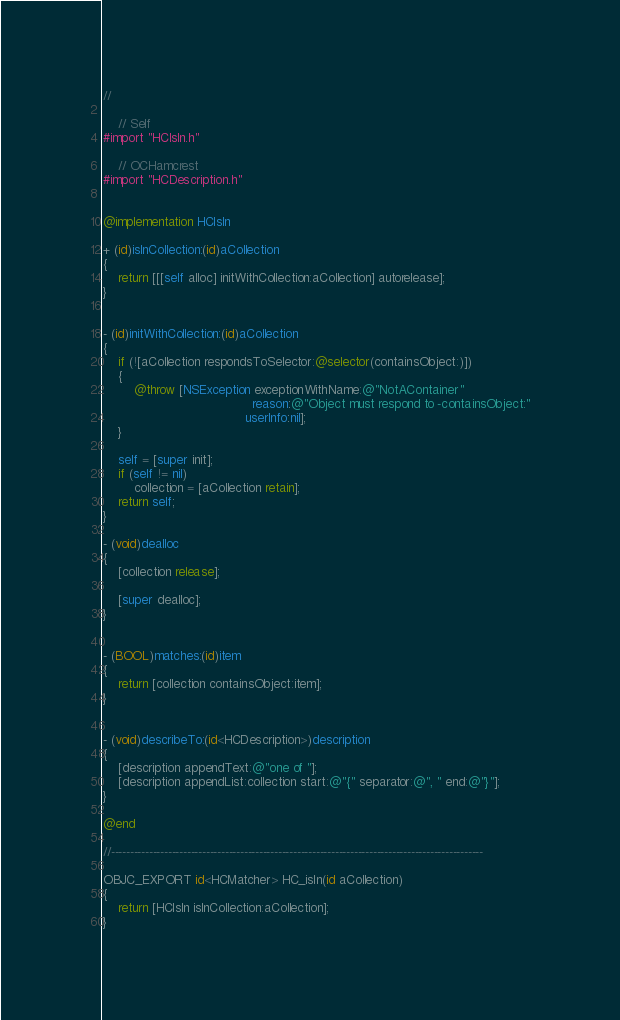<code> <loc_0><loc_0><loc_500><loc_500><_ObjectiveC_>//

    // Self
#import "HCIsIn.h"

    // OCHamcrest
#import "HCDescription.h"


@implementation HCIsIn

+ (id)isInCollection:(id)aCollection
{
    return [[[self alloc] initWithCollection:aCollection] autorelease];
}


- (id)initWithCollection:(id)aCollection
{
    if (![aCollection respondsToSelector:@selector(containsObject:)])
    {
        @throw [NSException exceptionWithName:@"NotAContainer"
                                       reason:@"Object must respond to -containsObject:"
                                     userInfo:nil];
    }
    
    self = [super init];
    if (self != nil)
        collection = [aCollection retain];
    return self;
}

- (void)dealloc
{
    [collection release];
    
    [super dealloc];
}


- (BOOL)matches:(id)item
{
    return [collection containsObject:item];
}


- (void)describeTo:(id<HCDescription>)description
{
    [description appendText:@"one of "];
    [description appendList:collection start:@"{" separator:@", " end:@"}"];
}

@end

//--------------------------------------------------------------------------------------------------

OBJC_EXPORT id<HCMatcher> HC_isIn(id aCollection)
{
    return [HCIsIn isInCollection:aCollection];
}
</code> 